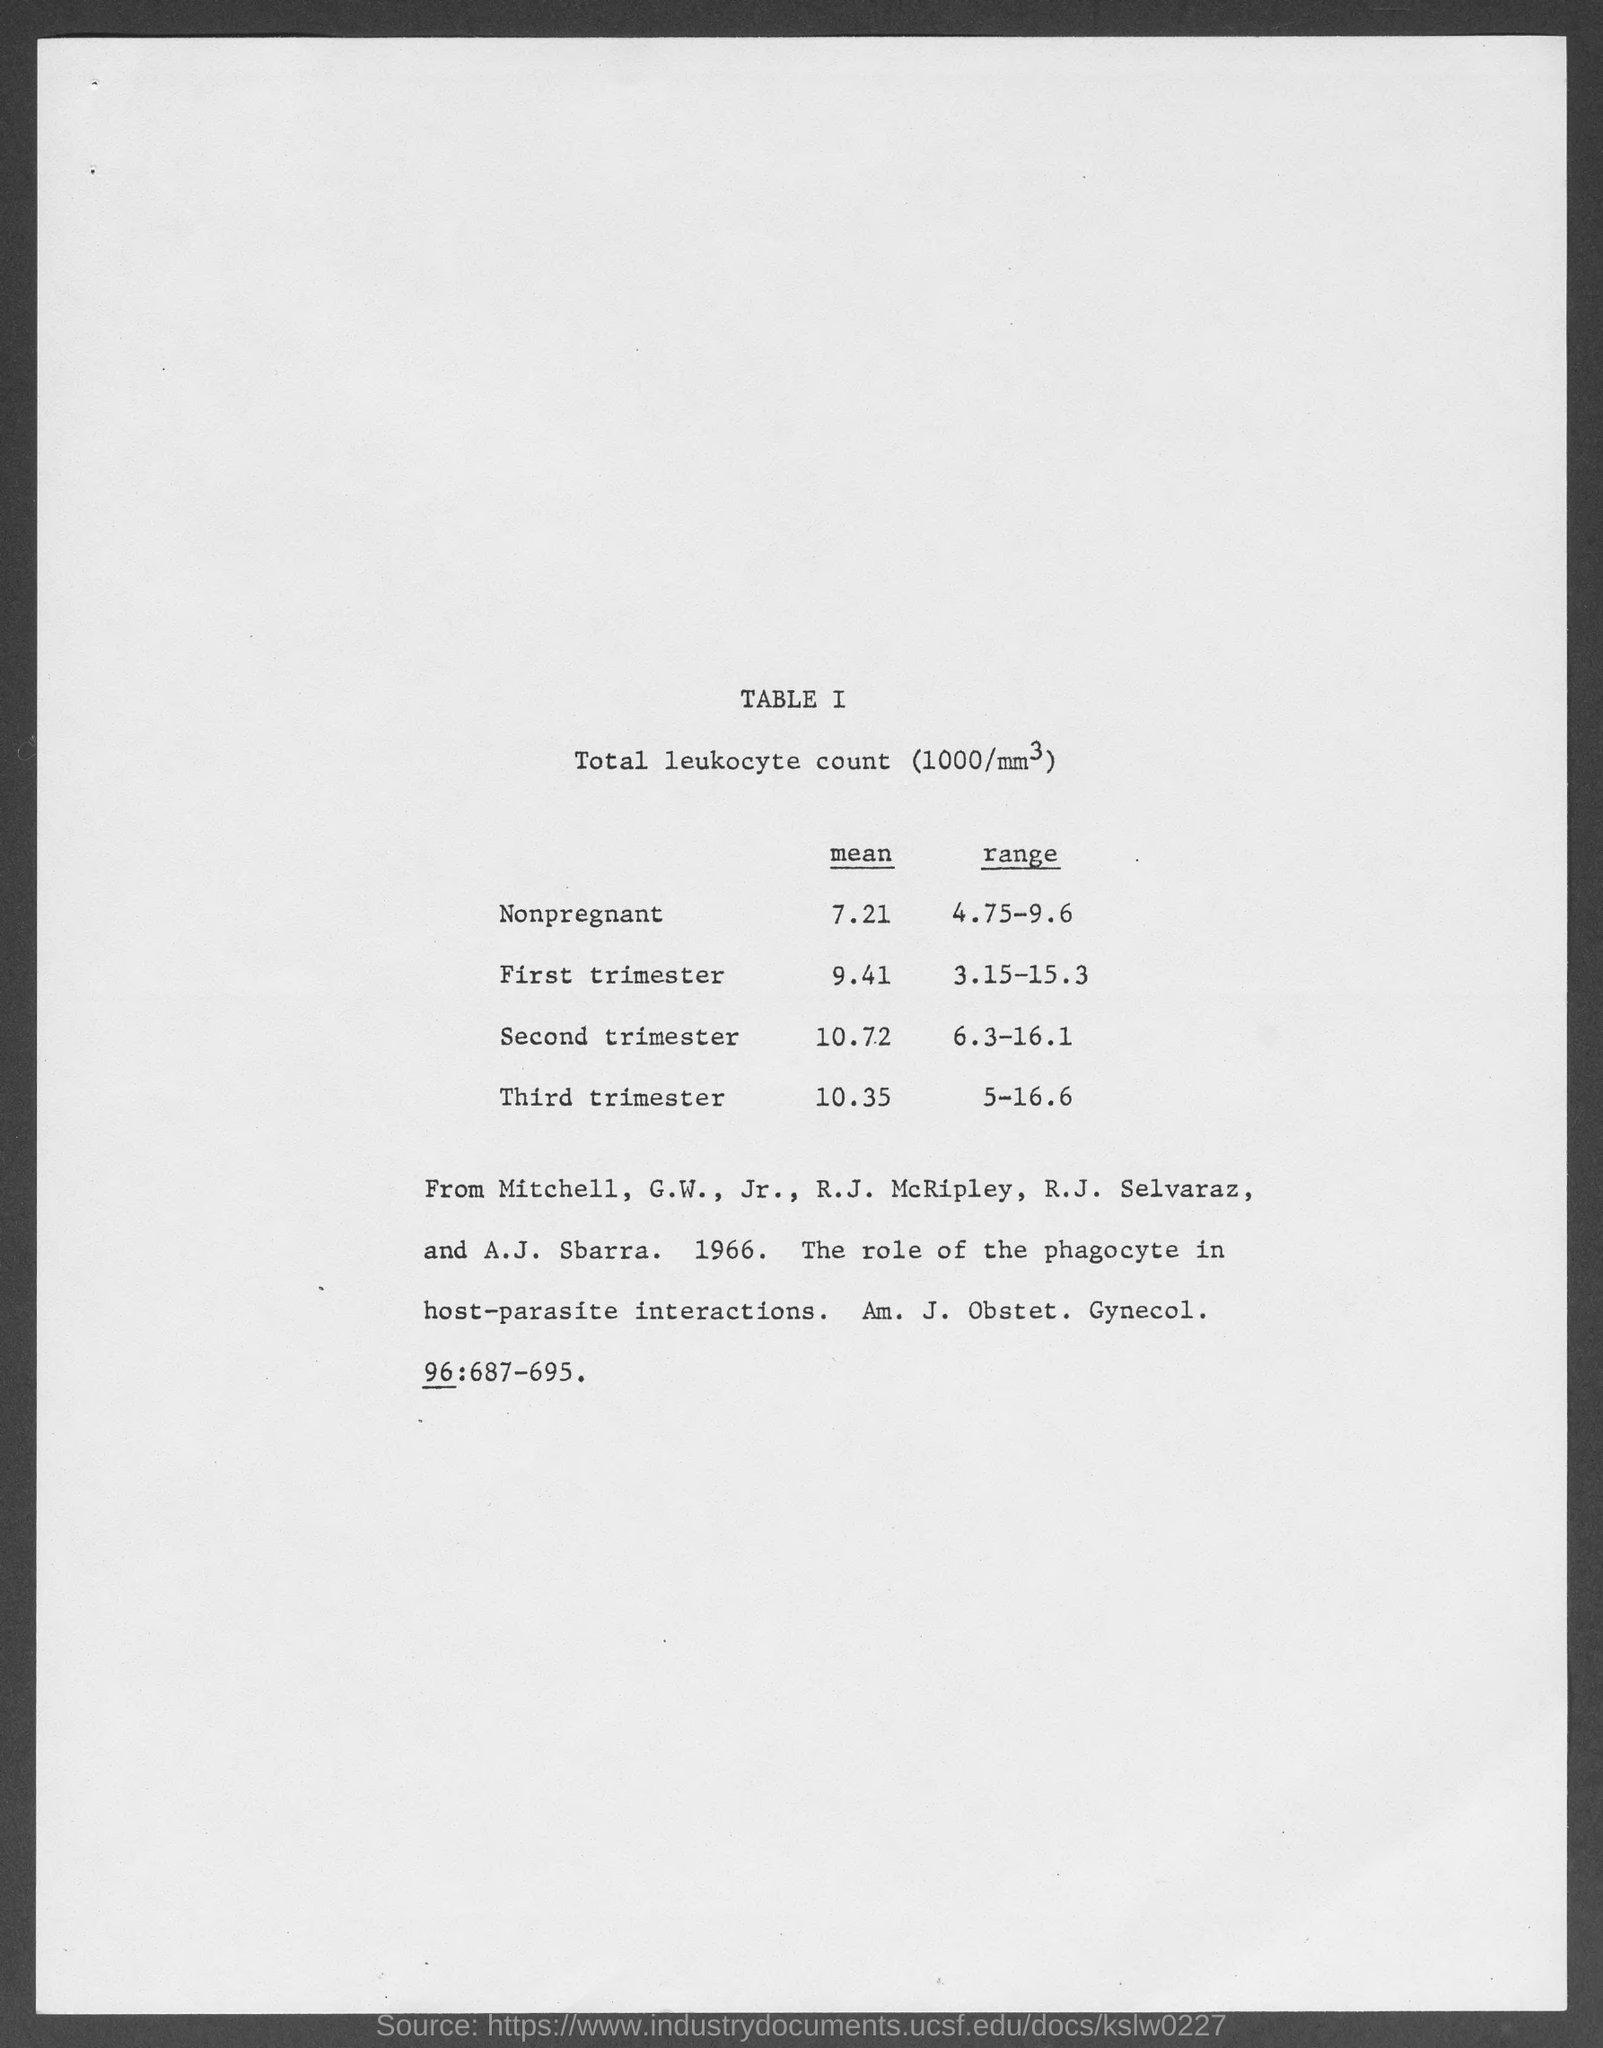What does TABLE I describe?
Make the answer very short. Total leukocyte count (1000/mm3). What is the mean of total leukocyte count (1000/mm3) in nonpregnant women?
Give a very brief answer. 7.21. What is the mean of total leukocyte count (1000/mm3) in the First trimester?
Offer a terse response. 9.41. What is the range of total leukocyte count (1000/mm3) in the third trimester?
Make the answer very short. 5-16.6. What is the range of total leukocyte count (1000/mm3) in the First trimester?
Give a very brief answer. 3.15-15.3. What is the mean of total leukocyte count (1000/mm3) in the second trimester?
Your answer should be compact. 10.72. 